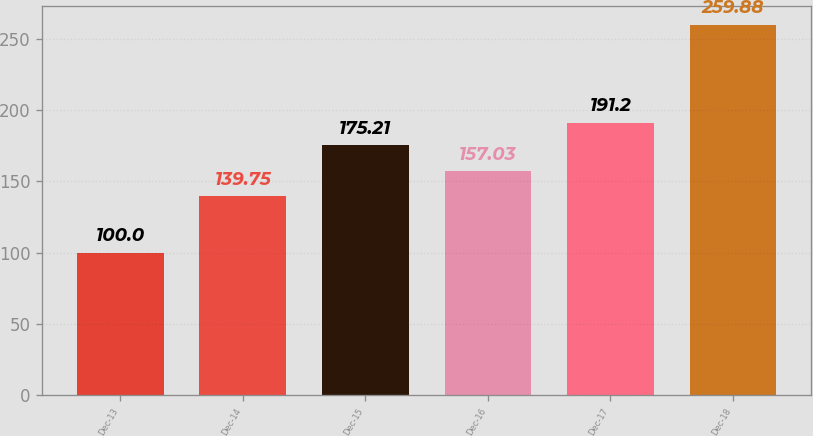<chart> <loc_0><loc_0><loc_500><loc_500><bar_chart><fcel>Dec-13<fcel>Dec-14<fcel>Dec-15<fcel>Dec-16<fcel>Dec-17<fcel>Dec-18<nl><fcel>100<fcel>139.75<fcel>175.21<fcel>157.03<fcel>191.2<fcel>259.88<nl></chart> 